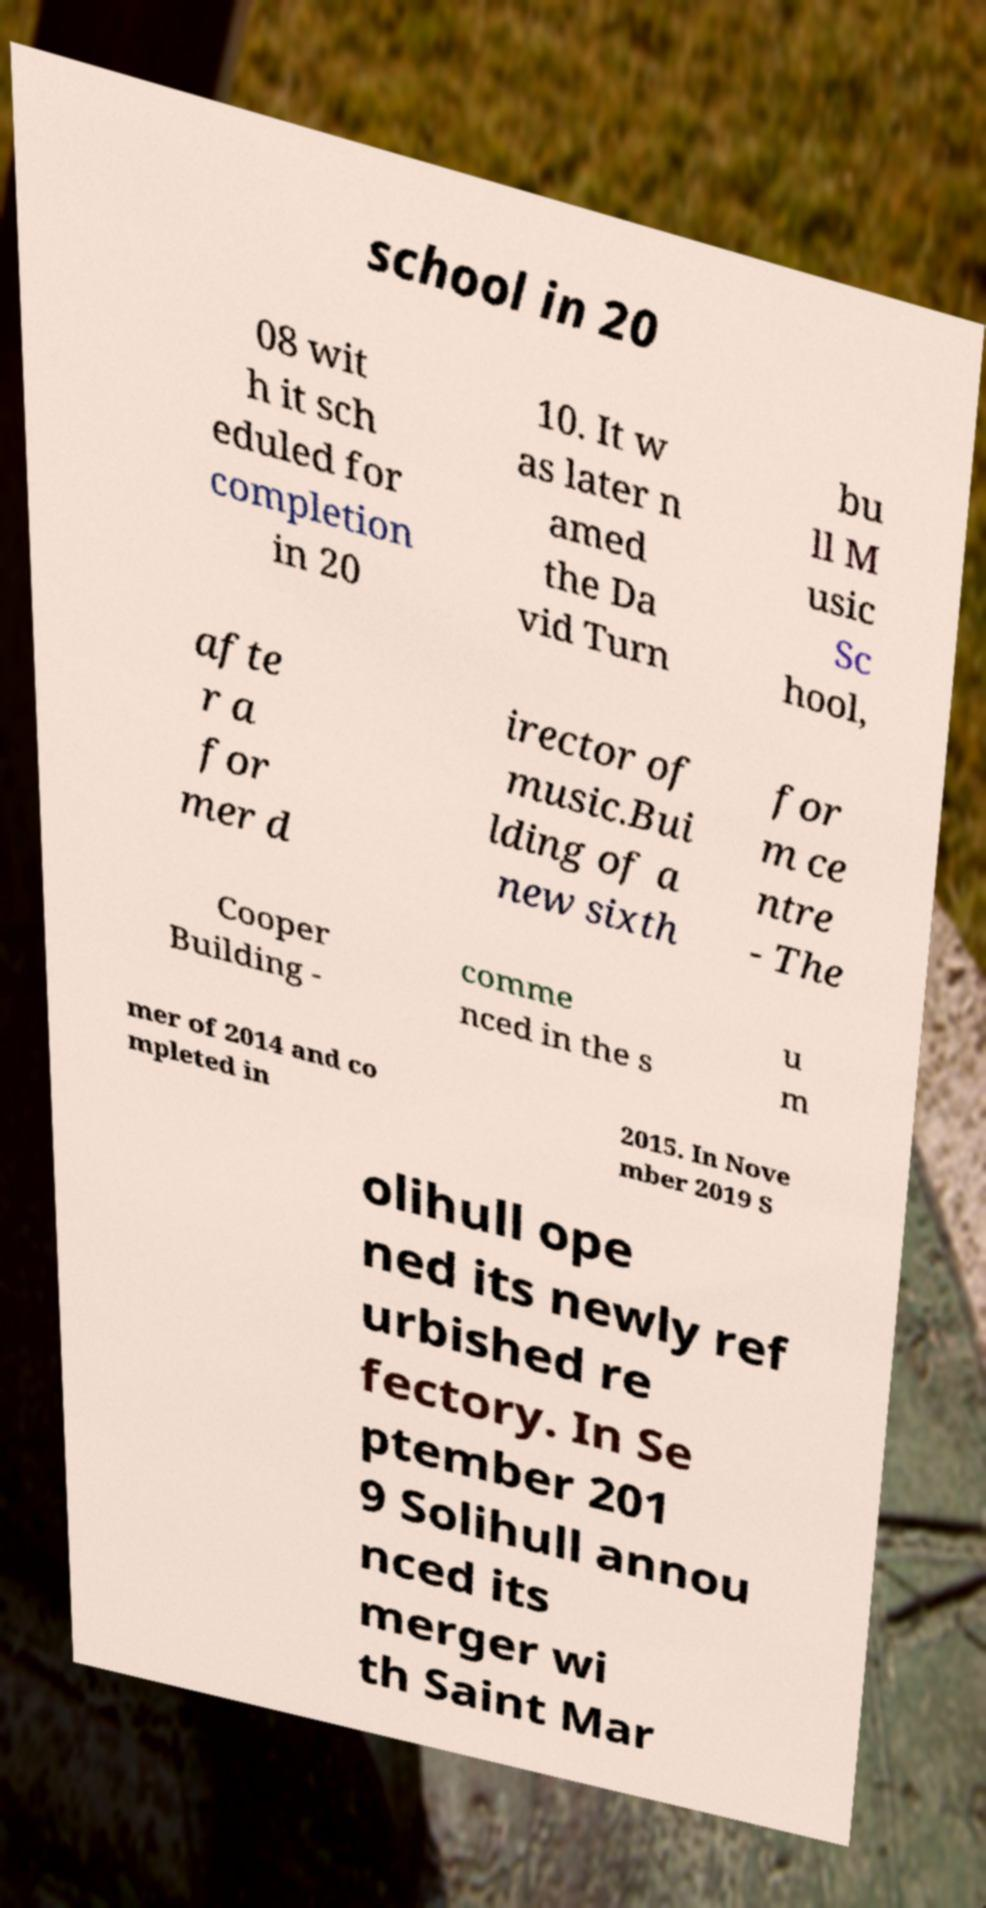What messages or text are displayed in this image? I need them in a readable, typed format. school in 20 08 wit h it sch eduled for completion in 20 10. It w as later n amed the Da vid Turn bu ll M usic Sc hool, afte r a for mer d irector of music.Bui lding of a new sixth for m ce ntre - The Cooper Building - comme nced in the s u m mer of 2014 and co mpleted in 2015. In Nove mber 2019 S olihull ope ned its newly ref urbished re fectory. In Se ptember 201 9 Solihull annou nced its merger wi th Saint Mar 